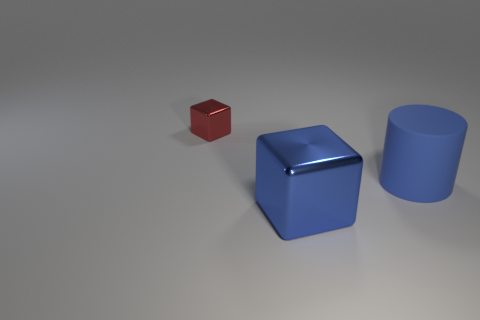Add 3 blocks. How many objects exist? 6 Subtract all cylinders. How many objects are left? 2 Add 2 big blue shiny cubes. How many big blue shiny cubes are left? 3 Add 1 blue spheres. How many blue spheres exist? 1 Subtract 0 brown cylinders. How many objects are left? 3 Subtract all brown cylinders. Subtract all cyan blocks. How many cylinders are left? 1 Subtract all large rubber things. Subtract all large green blocks. How many objects are left? 2 